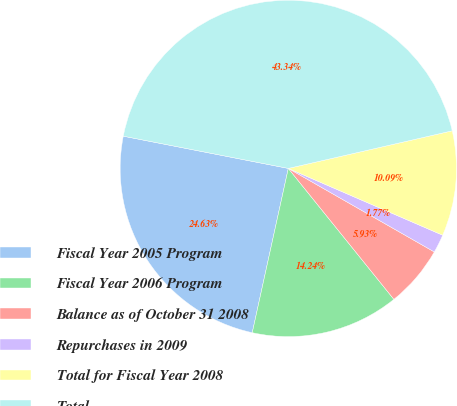Convert chart to OTSL. <chart><loc_0><loc_0><loc_500><loc_500><pie_chart><fcel>Fiscal Year 2005 Program<fcel>Fiscal Year 2006 Program<fcel>Balance as of October 31 2008<fcel>Repurchases in 2009<fcel>Total for Fiscal Year 2008<fcel>Total<nl><fcel>24.63%<fcel>14.24%<fcel>5.93%<fcel>1.77%<fcel>10.09%<fcel>43.34%<nl></chart> 